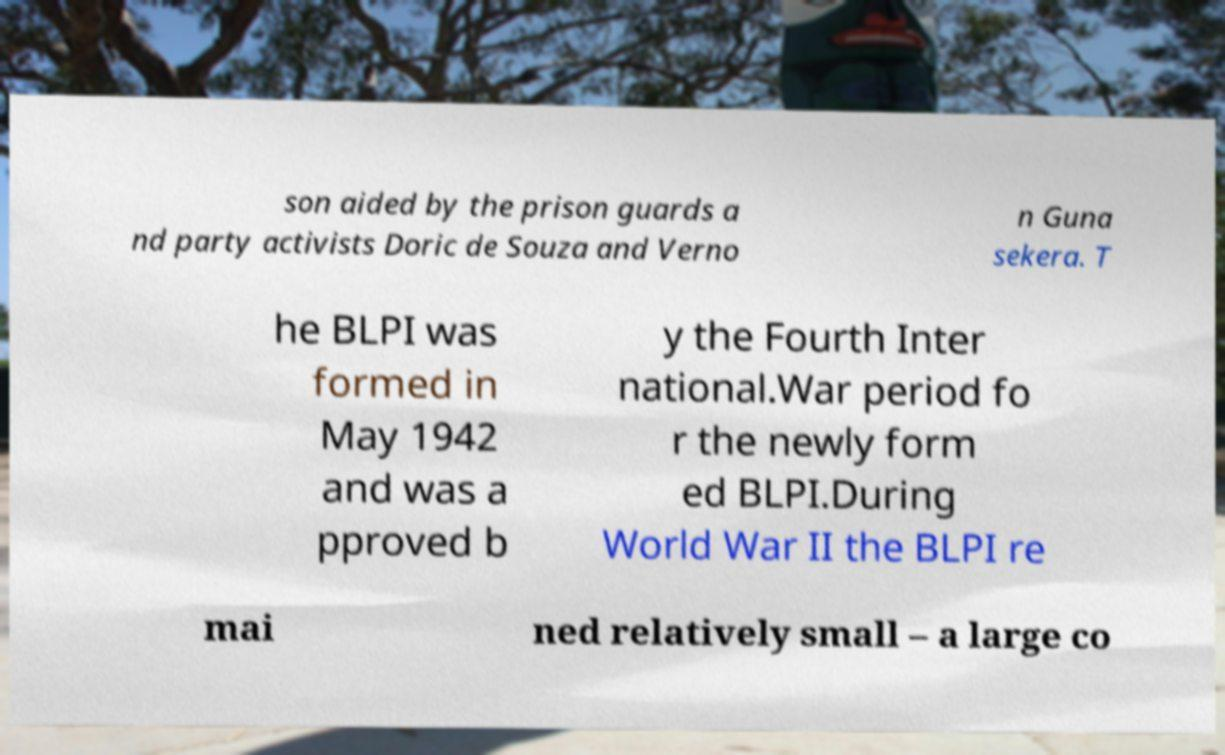There's text embedded in this image that I need extracted. Can you transcribe it verbatim? son aided by the prison guards a nd party activists Doric de Souza and Verno n Guna sekera. T he BLPI was formed in May 1942 and was a pproved b y the Fourth Inter national.War period fo r the newly form ed BLPI.During World War II the BLPI re mai ned relatively small – a large co 